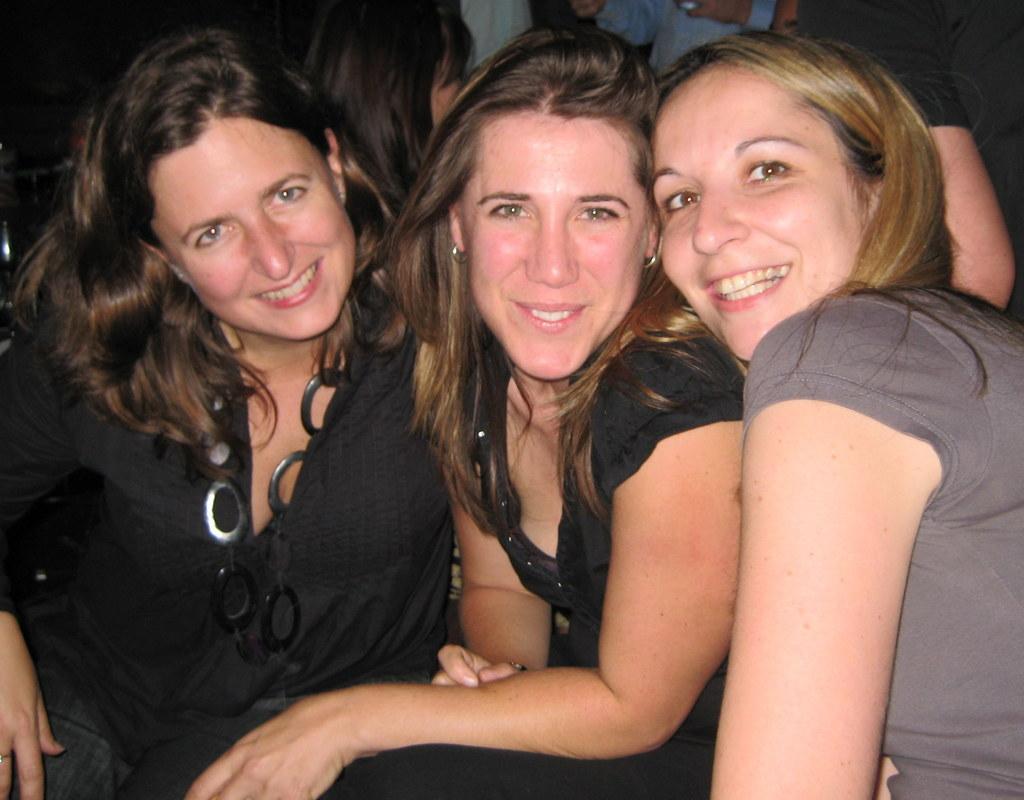In one or two sentences, can you explain what this image depicts? In the picture we can see three women are sitting together and smiling, two women are wearing black dresses and one woman is wearing gray color dress. 